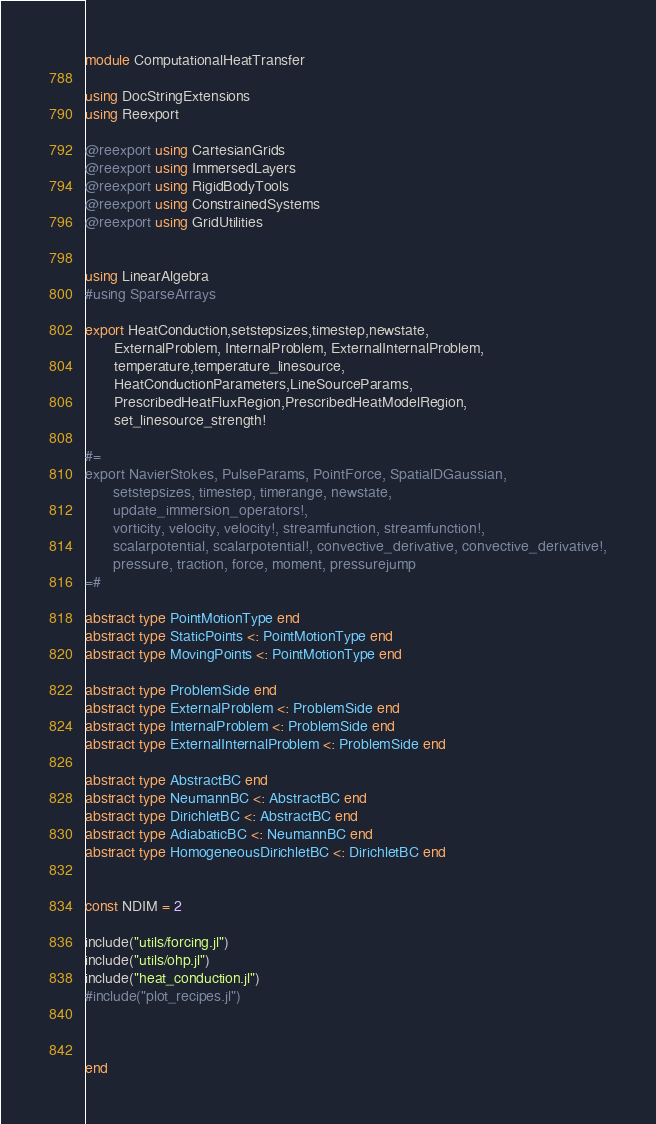<code> <loc_0><loc_0><loc_500><loc_500><_Julia_>module ComputationalHeatTransfer

using DocStringExtensions
using Reexport

@reexport using CartesianGrids
@reexport using ImmersedLayers
@reexport using RigidBodyTools
@reexport using ConstrainedSystems
@reexport using GridUtilities


using LinearAlgebra
#using SparseArrays

export HeatConduction,setstepsizes,timestep,newstate,
       ExternalProblem, InternalProblem, ExternalInternalProblem,
       temperature,temperature_linesource,
       HeatConductionParameters,LineSourceParams,
       PrescribedHeatFluxRegion,PrescribedHeatModelRegion,
       set_linesource_strength!

#=
export NavierStokes, PulseParams, PointForce, SpatialDGaussian,
       setstepsizes, timestep, timerange, newstate,
       update_immersion_operators!,
       vorticity, velocity, velocity!, streamfunction, streamfunction!,
       scalarpotential, scalarpotential!, convective_derivative, convective_derivative!,
       pressure, traction, force, moment, pressurejump
=#

abstract type PointMotionType end
abstract type StaticPoints <: PointMotionType end
abstract type MovingPoints <: PointMotionType end

abstract type ProblemSide end
abstract type ExternalProblem <: ProblemSide end
abstract type InternalProblem <: ProblemSide end
abstract type ExternalInternalProblem <: ProblemSide end

abstract type AbstractBC end
abstract type NeumannBC <: AbstractBC end
abstract type DirichletBC <: AbstractBC end
abstract type AdiabaticBC <: NeumannBC end
abstract type HomogeneousDirichletBC <: DirichletBC end


const NDIM = 2

include("utils/forcing.jl")
include("utils/ohp.jl")
include("heat_conduction.jl")
#include("plot_recipes.jl")



end
</code> 